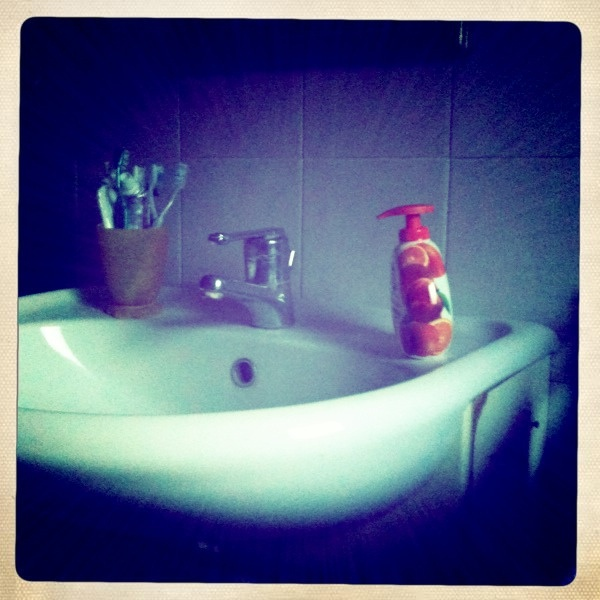Describe the objects in this image and their specific colors. I can see sink in beige, navy, teal, and turquoise tones, cup in beige, purple, and navy tones, toothbrush in beige, gray, blue, and darkblue tones, toothbrush in beige, gray, blue, navy, and teal tones, and toothbrush in beige, navy, blue, and teal tones in this image. 